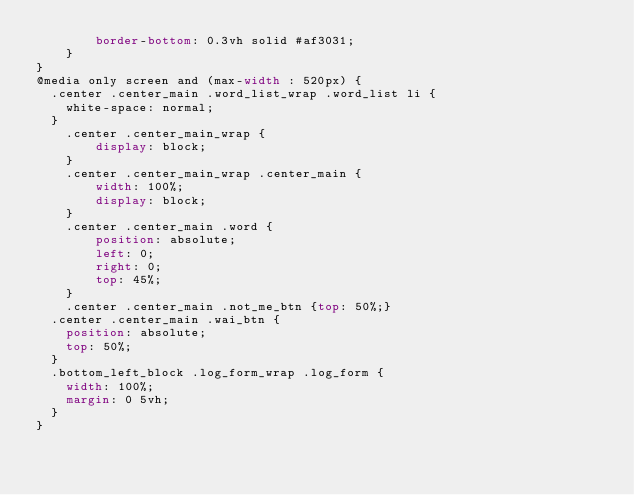Convert code to text. <code><loc_0><loc_0><loc_500><loc_500><_CSS_>        border-bottom: 0.3vh solid #af3031;
    }
}
@media only screen and (max-width : 520px) {
	.center .center_main .word_list_wrap .word_list li {
		white-space: normal;
	}
    .center .center_main_wrap {
        display: block;
    }
    .center .center_main_wrap .center_main {
        width: 100%;
        display: block;
    }
    .center .center_main .word {
        position: absolute;
        left: 0;
        right: 0;
        top: 45%;
    }
    .center .center_main .not_me_btn {top: 50%;}
	.center .center_main .wai_btn {
		position: absolute;
		top: 50%;
	}
	.bottom_left_block .log_form_wrap .log_form {
		width: 100%;
		margin: 0 5vh;
	}
}
</code> 